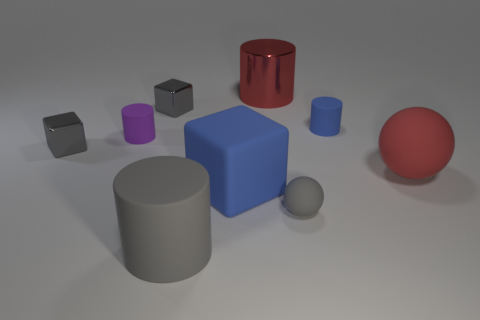Add 1 cylinders. How many objects exist? 10 Subtract all spheres. How many objects are left? 7 Subtract 0 yellow cylinders. How many objects are left? 9 Subtract all small rubber spheres. Subtract all gray rubber spheres. How many objects are left? 7 Add 3 small gray blocks. How many small gray blocks are left? 5 Add 1 large gray rubber things. How many large gray rubber things exist? 2 